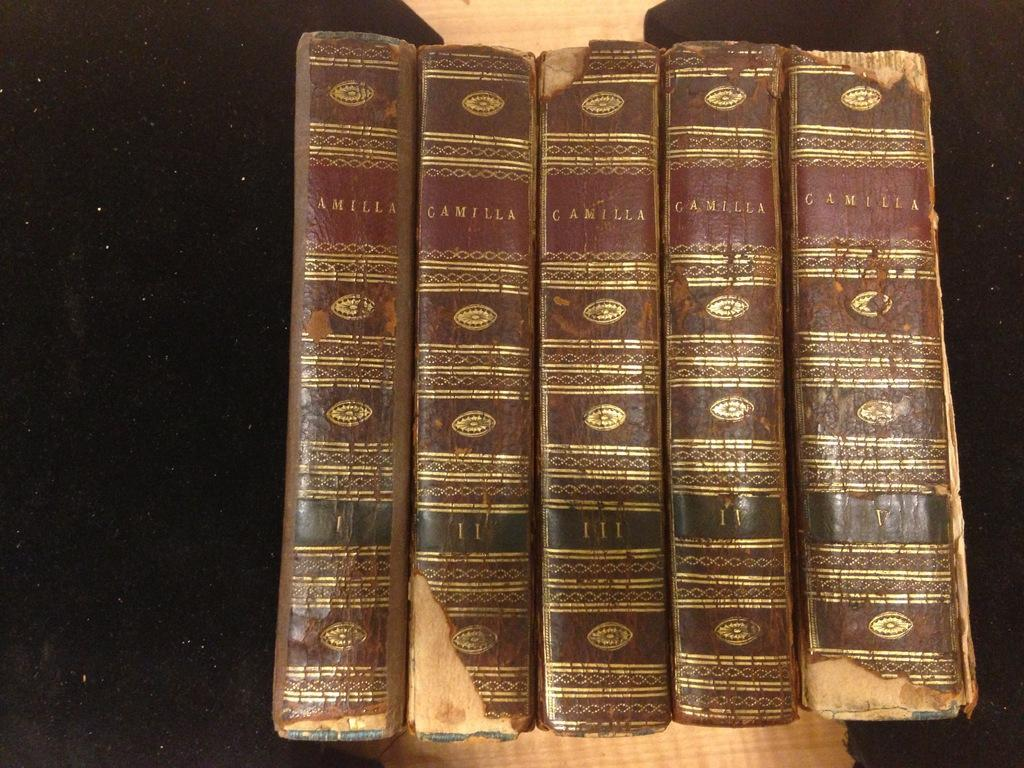<image>
Provide a brief description of the given image. A set of hard bound books by Camilla, volumes 1-5. 